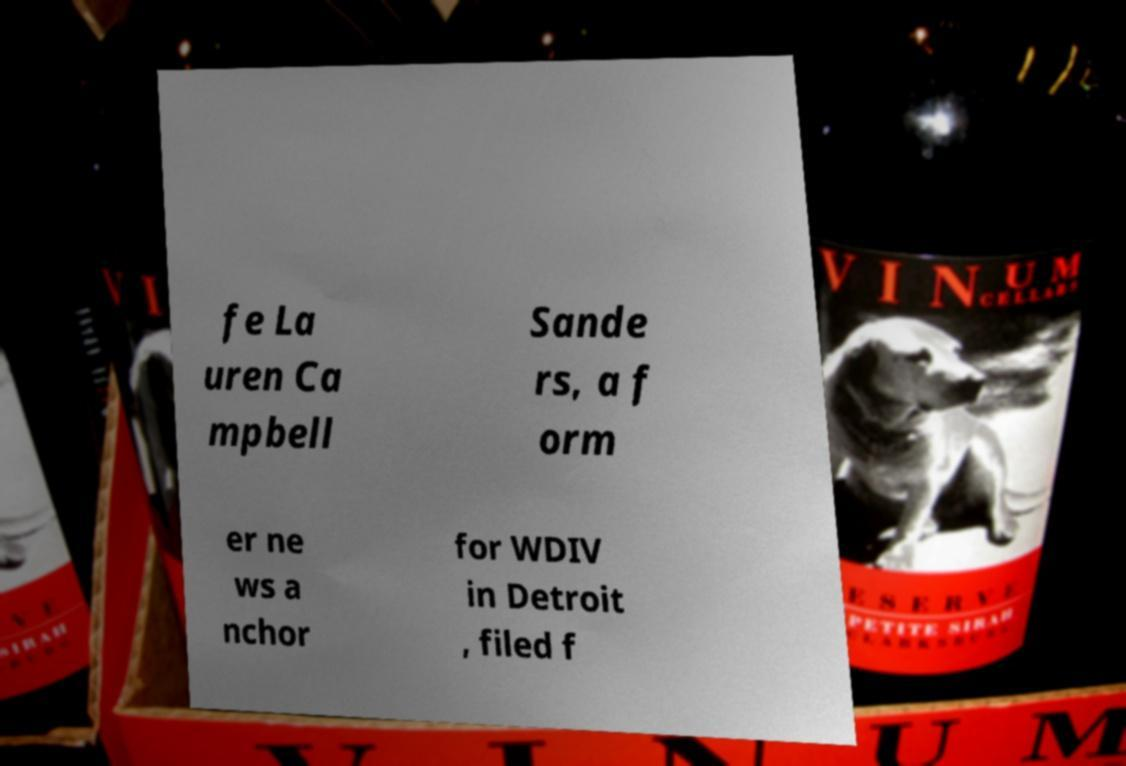There's text embedded in this image that I need extracted. Can you transcribe it verbatim? fe La uren Ca mpbell Sande rs, a f orm er ne ws a nchor for WDIV in Detroit , filed f 